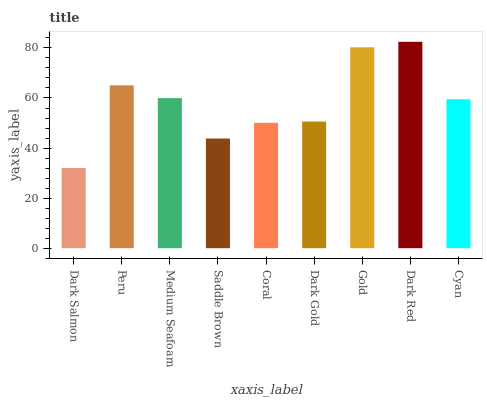Is Dark Salmon the minimum?
Answer yes or no. Yes. Is Dark Red the maximum?
Answer yes or no. Yes. Is Peru the minimum?
Answer yes or no. No. Is Peru the maximum?
Answer yes or no. No. Is Peru greater than Dark Salmon?
Answer yes or no. Yes. Is Dark Salmon less than Peru?
Answer yes or no. Yes. Is Dark Salmon greater than Peru?
Answer yes or no. No. Is Peru less than Dark Salmon?
Answer yes or no. No. Is Cyan the high median?
Answer yes or no. Yes. Is Cyan the low median?
Answer yes or no. Yes. Is Dark Gold the high median?
Answer yes or no. No. Is Dark Salmon the low median?
Answer yes or no. No. 